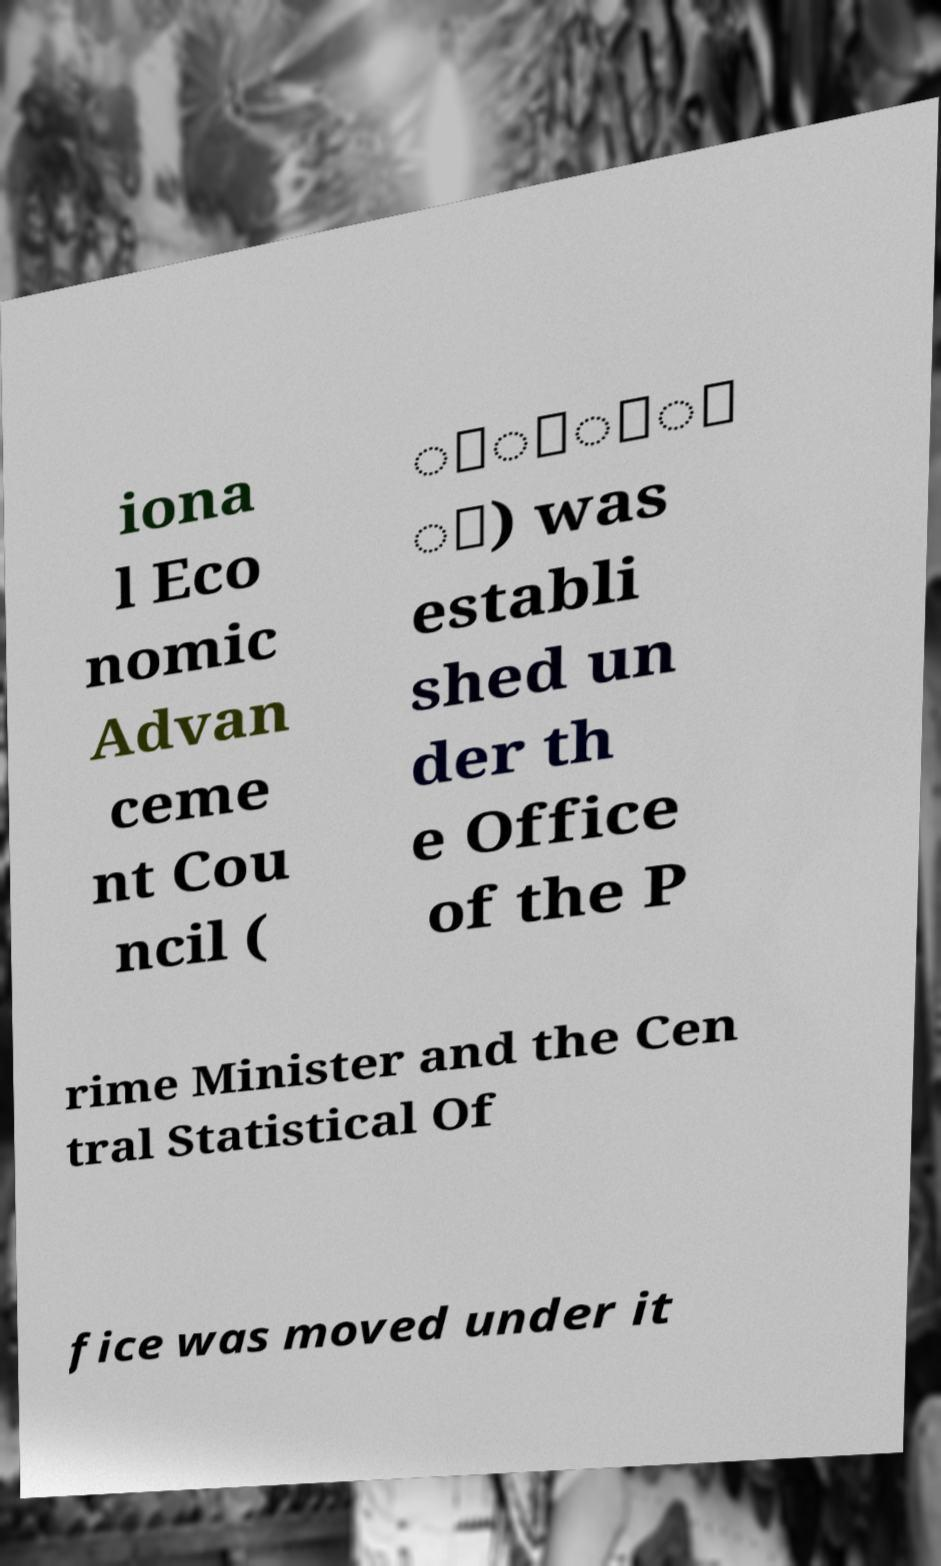I need the written content from this picture converted into text. Can you do that? iona l Eco nomic Advan ceme nt Cou ncil ( ััิ่ ิ) was establi shed un der th e Office of the P rime Minister and the Cen tral Statistical Of fice was moved under it 